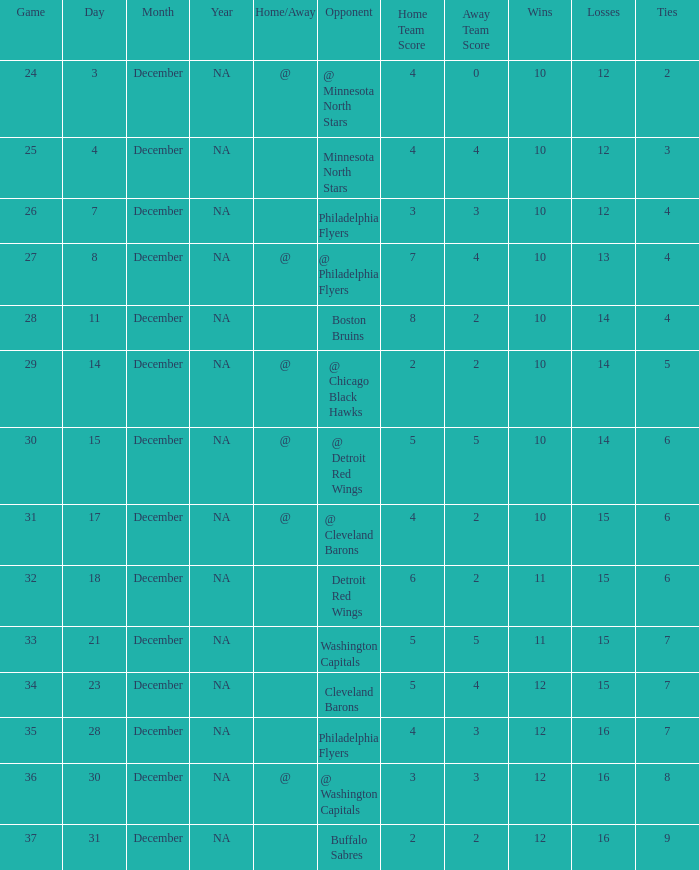What is Record, when Game is "24"? 10-12-2. 